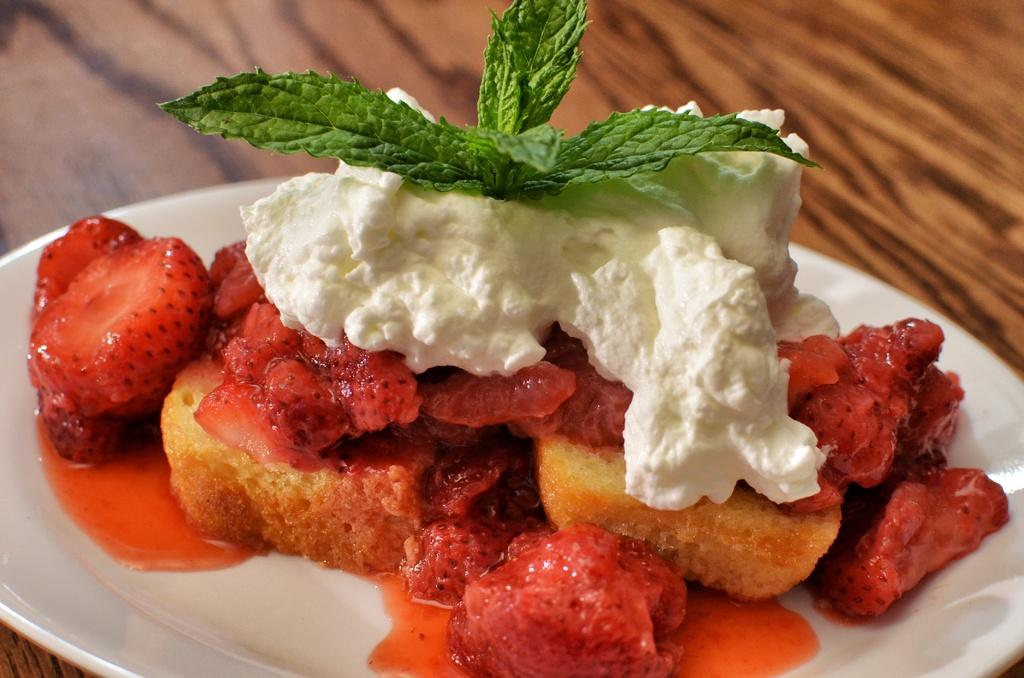What is on the plate that is visible in the image? The plate contains strawberries, bread, ice cream, and mint leaves. Where is the plate located in the image? The plate is on a wooden table. How is the parcel being used in the image? There is no parcel present in the image. What type of paste is being applied to the bread in the image? There is no paste being applied to the bread in the image. 